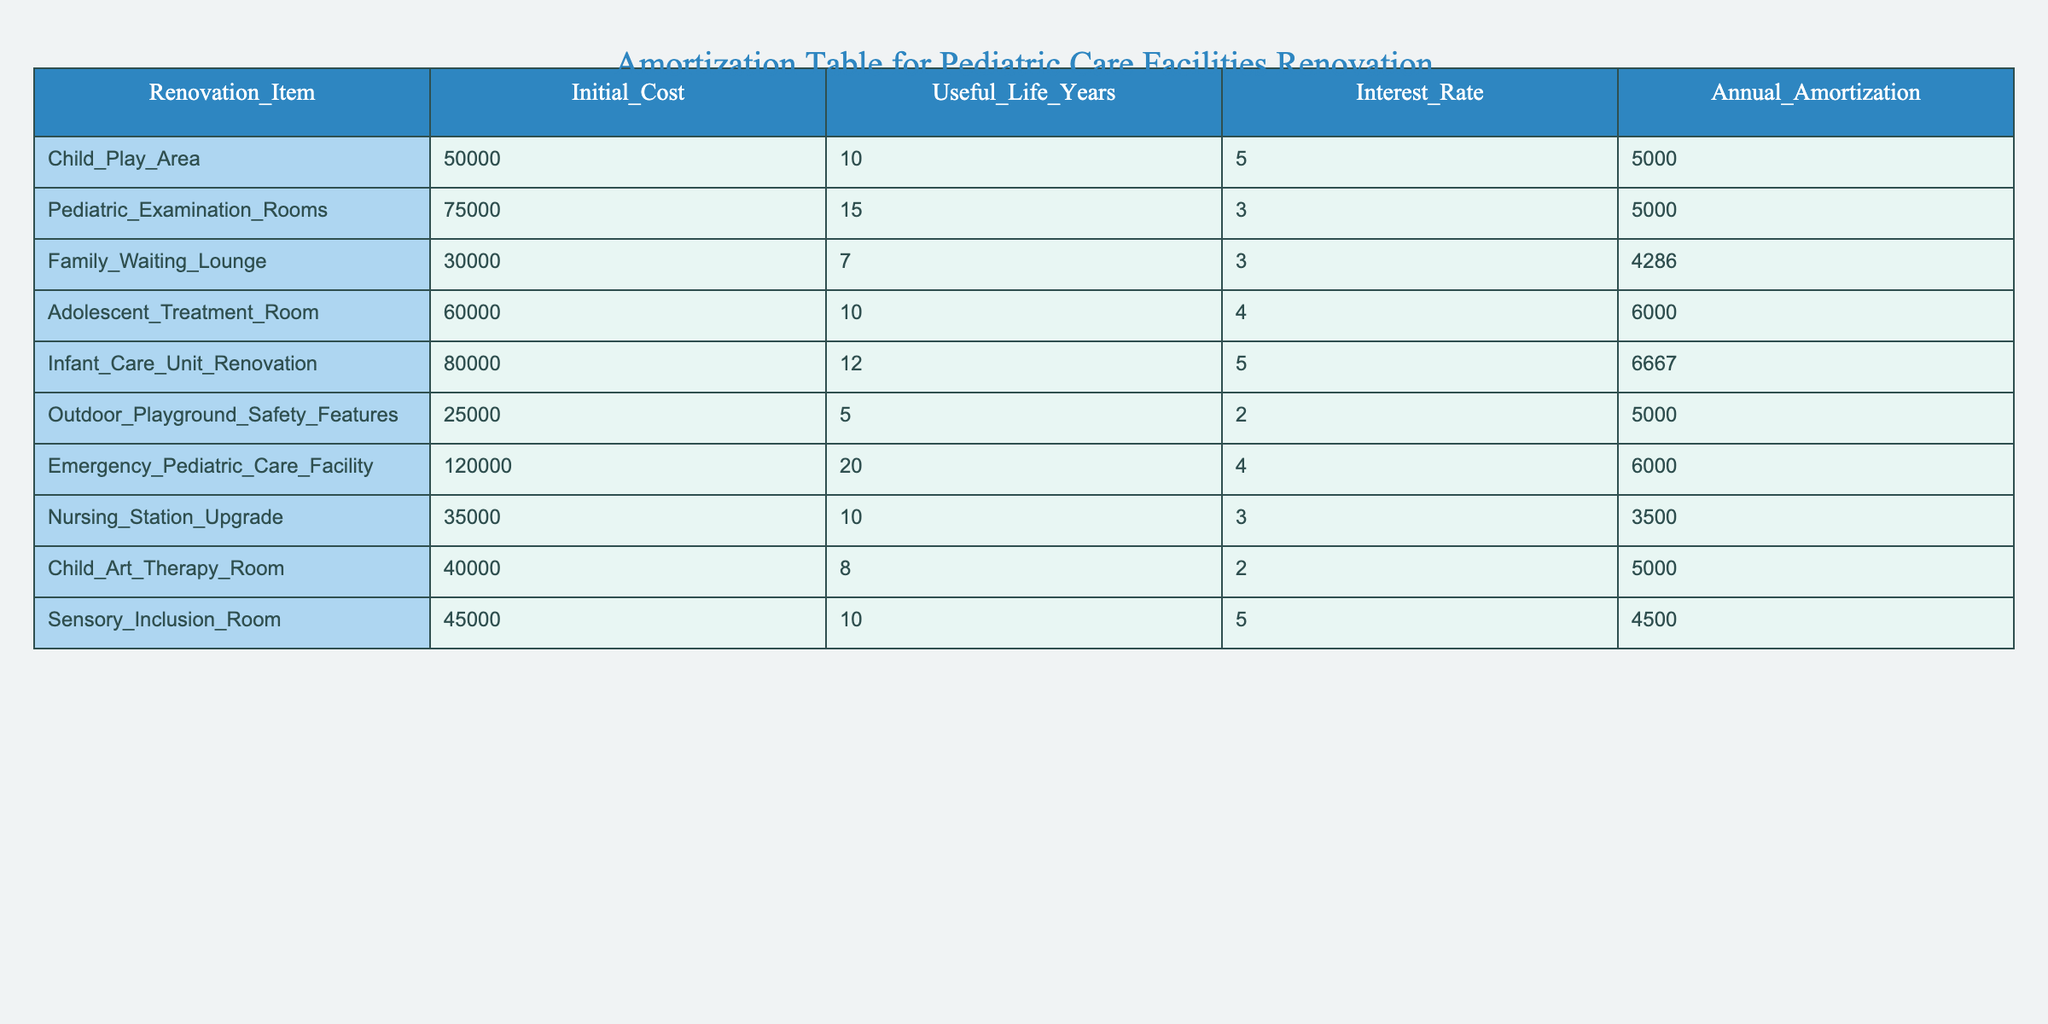What is the initial cost of the Child Play Area? The table lists the initial cost under the column for "Initial_Cost". For the Child Play Area, it is specified as 50000.
Answer: 50000 What is the annual amortization for the Pediatric Examination Rooms? Looking in the "Annual_Amortization" column of the table, the value for the Pediatric Examination Rooms is stated as 5000.
Answer: 5000 How many renovation items have an interest rate of 5%? By reviewing the "Interest_Rate" column, the renovation items with an interest rate of 5% are Child Play Area, Infant Care Unit Renovation, and Sensory Inclusion Room, which totals to 3 items.
Answer: 3 What is the total initial cost for all renovation items? We sum the "Initial_Cost" column values: 50000 + 75000 + 30000 + 60000 + 80000 + 25000 + 120000 + 35000 + 40000 + 45000 = 435000.
Answer: 435000 Is the Family Waiting Lounge renovation amortized over more than 7 years? The useful life for the Family Waiting Lounge is explicitly stated as 7 years, indicating it is not amortized over more than that time frame.
Answer: No Which renovation item has the highest annual amortization? The "Annual_Amortization" column shows the highest value listed is 6667 for the Infant Care Unit Renovation, making it the item with the largest annual amortization expense.
Answer: 6667 What is the average useful life of the renovation items listed? To find the average, we sum the "Useful_Life_Years" values: 10 + 15 + 7 + 10 + 12 + 5 + 20 + 10 + 8 + 10 = 117. Then, dividing by the number of items (10) gives us 117/10 = 11.7 years.
Answer: 11.7 How much less is the annual amortization for the Nursing Station Upgrade compared to the Adolescent Treatment Room? The annual amortization for the Nursing Station Upgrade is 3500 and for the Adolescent Treatment Room it is 6000. The difference is calculated by 6000 - 3500 = 2500.
Answer: 2500 Is there a renovation item with both an initial cost above 60000 and an interest rate below 4%? Reviewing the table reveals that there are no items meeting both criteria; all items with an initial cost above 60000 (Emergency Pediatric Care Facility, Infant Care Unit Renovation, and Adolescent Treatment Room) have interest rates of 4% or higher.
Answer: No 